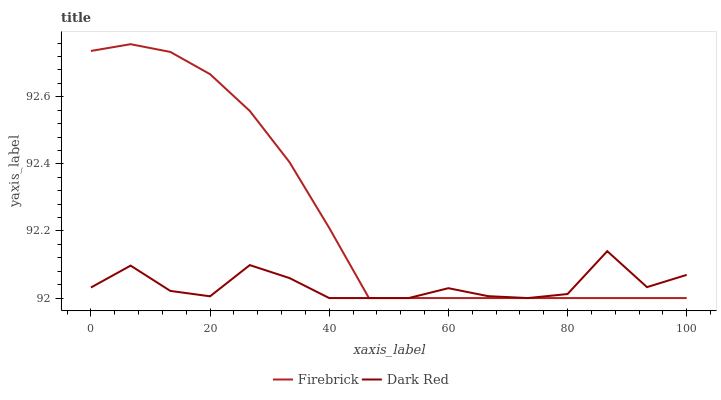Does Dark Red have the minimum area under the curve?
Answer yes or no. Yes. Does Firebrick have the maximum area under the curve?
Answer yes or no. Yes. Does Firebrick have the minimum area under the curve?
Answer yes or no. No. Is Firebrick the smoothest?
Answer yes or no. Yes. Is Dark Red the roughest?
Answer yes or no. Yes. Is Firebrick the roughest?
Answer yes or no. No. Does Dark Red have the lowest value?
Answer yes or no. Yes. Does Firebrick have the highest value?
Answer yes or no. Yes. Does Firebrick intersect Dark Red?
Answer yes or no. Yes. Is Firebrick less than Dark Red?
Answer yes or no. No. Is Firebrick greater than Dark Red?
Answer yes or no. No. 